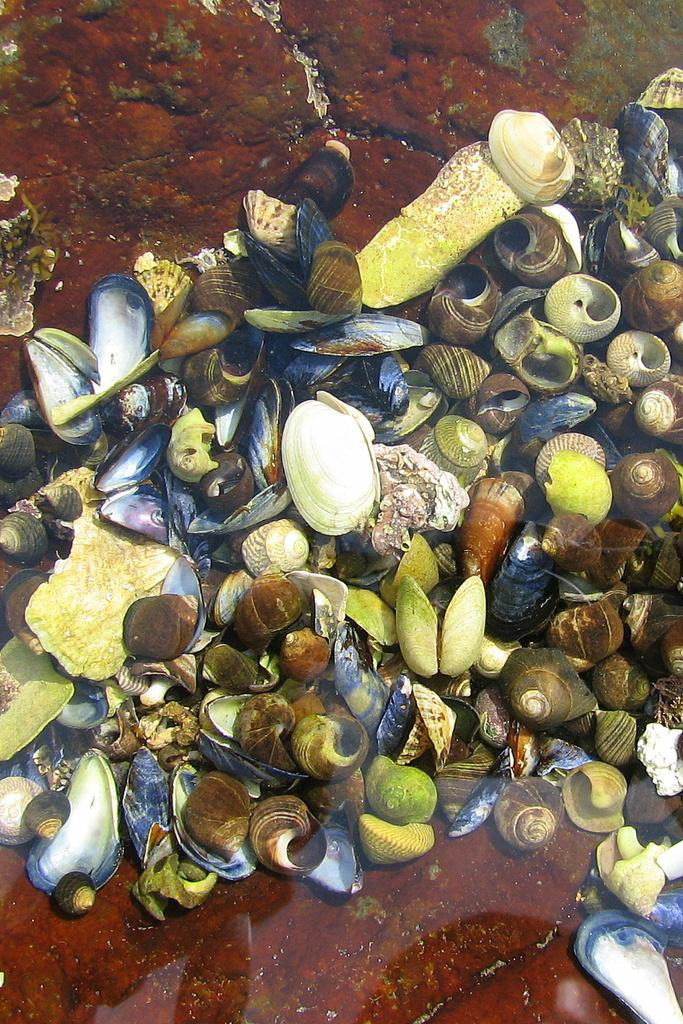What is the main subject of the image? The main subject of the image is seashells. Where are the seashells located in the image? The seashells are in the center of the image. What type of quince can be seen growing on the seashells in the image? There is no quince present in the image, as it features seashells and not plants. 